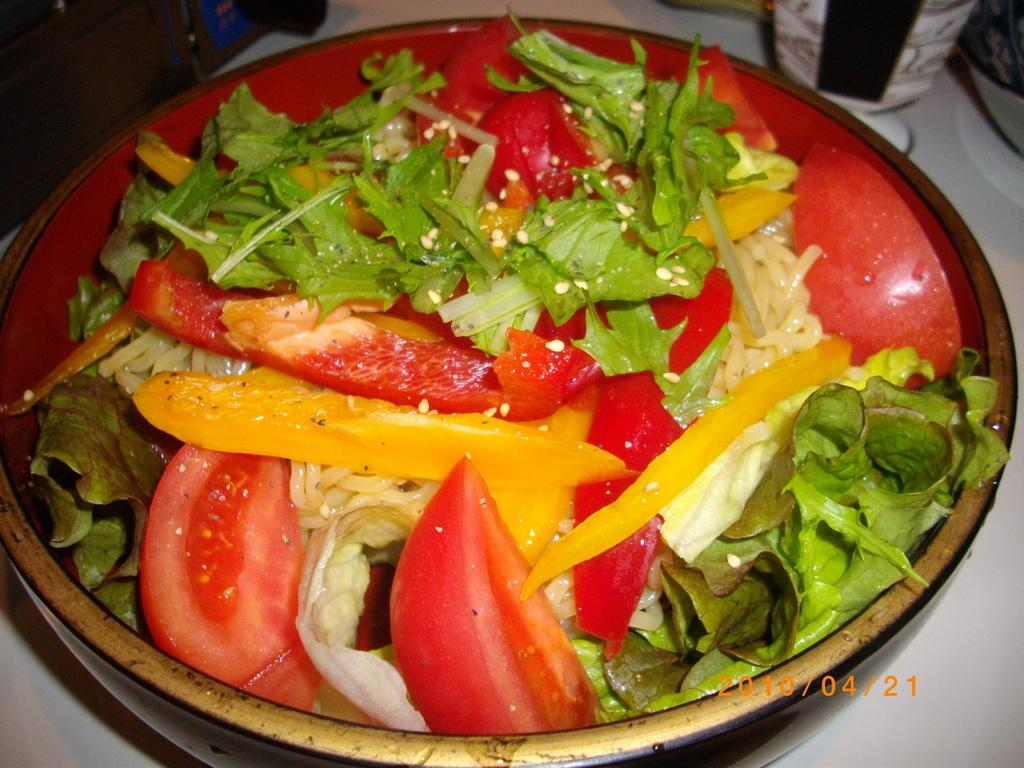What is the main subject of the image? There is a food item in a bowl in the image. What is the food item placed on? The food item is on an object. Can you describe anything visible in the background of the image? There are items visible in the background of the image. Is there any additional information about the image itself? There is a watermark on the image. What type of watch is visible on the food item in the image? There is no watch present on the food item in the image. What kind of flowers can be seen growing around the bowl in the image? There are no flowers visible in the image; it only features a food item in a bowl and items in the background. 